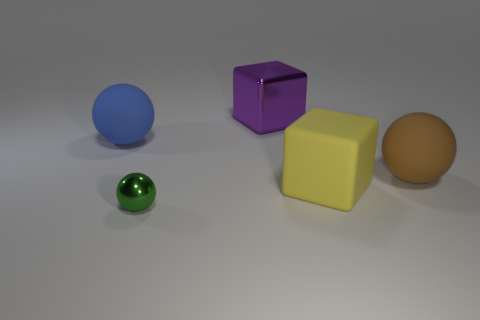Can you tell me which objects in the image have a reflective surface? The purple cube in the center has a reflective metallic surface that displays the environment and the objects around it. 